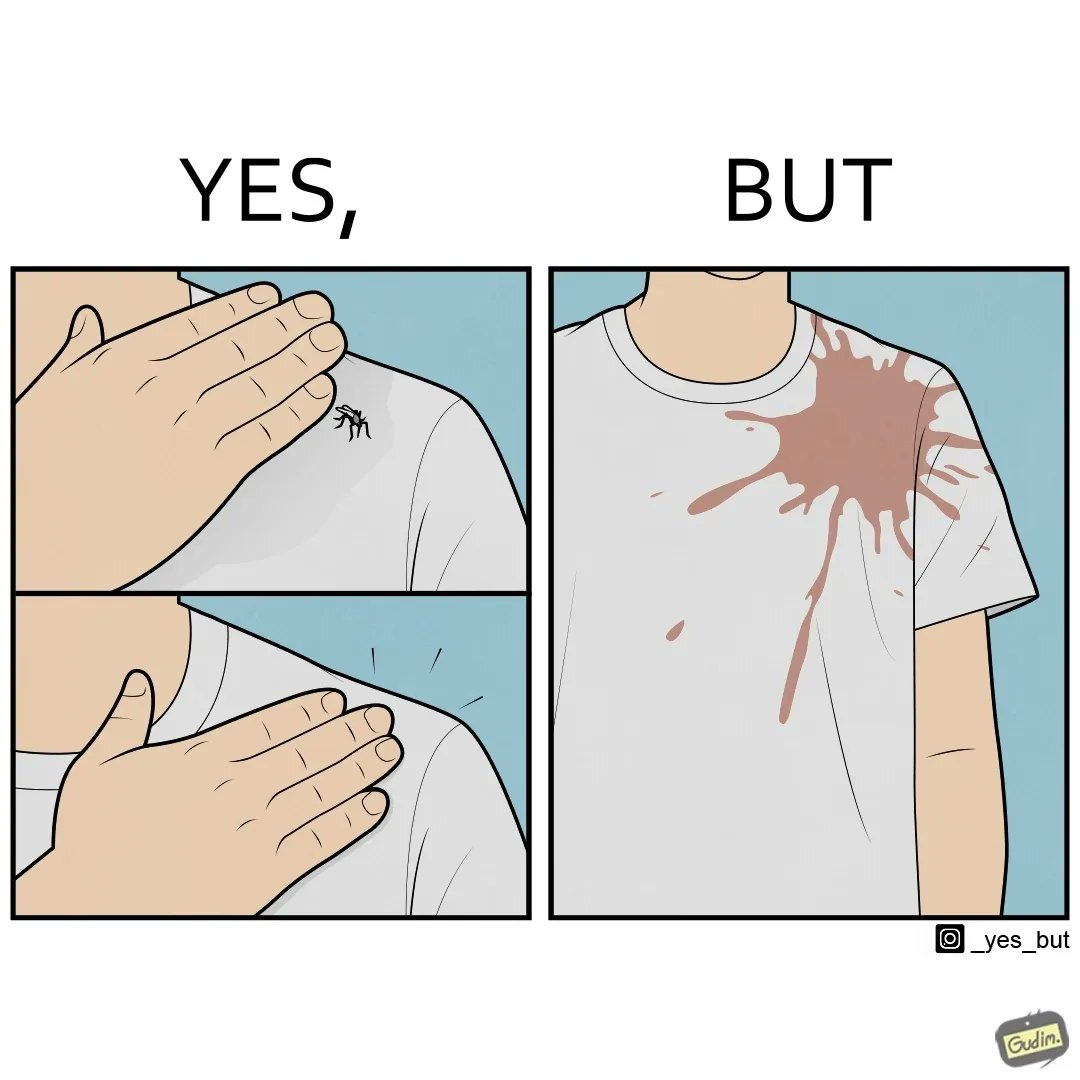Describe what you see in the left and right parts of this image. In the left part of the image: It is a set of two images of a man killing a mosquito by hand. In the right part of the image: It is man with red liquid smeared on his t-shirt 